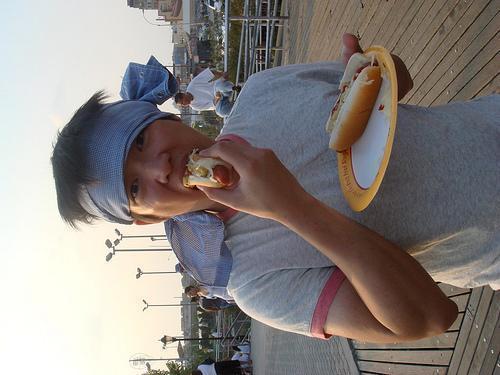How many hot dogs are on the plate?
Give a very brief answer. 1. 